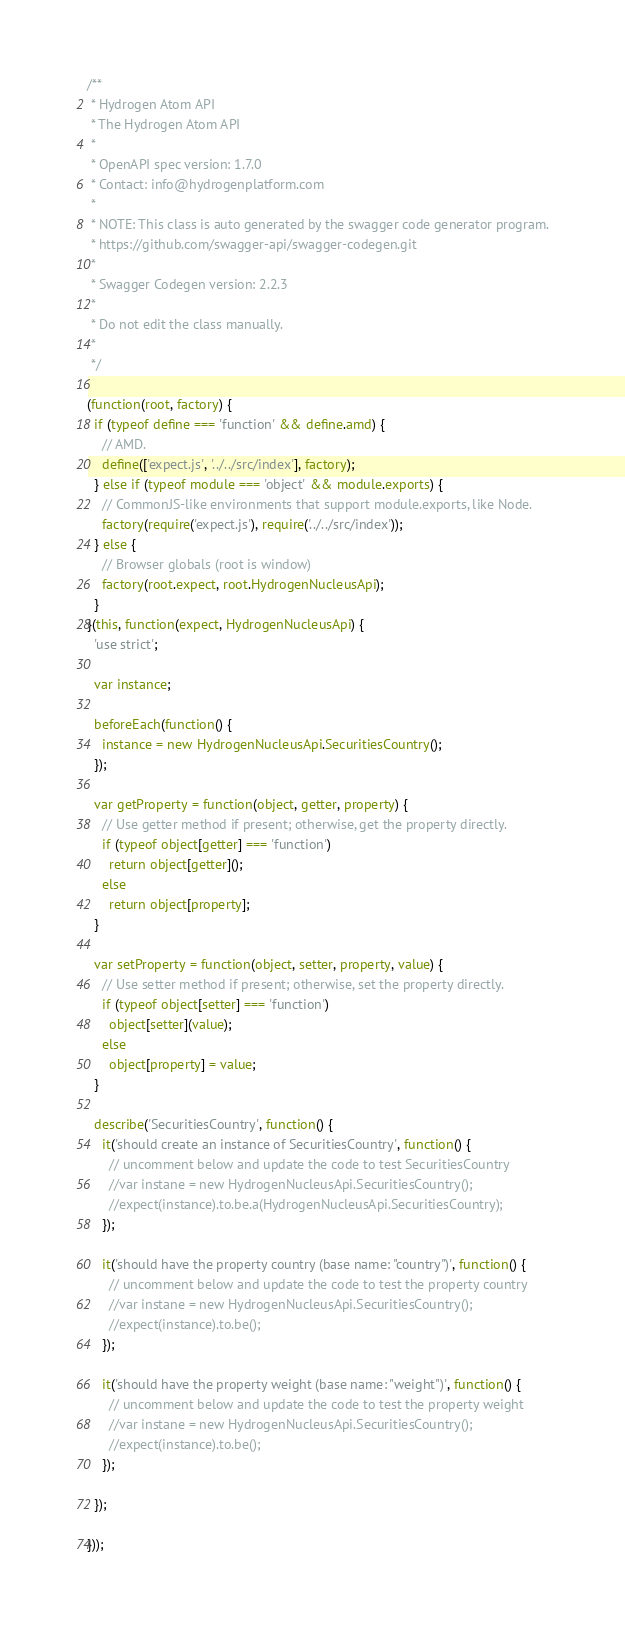<code> <loc_0><loc_0><loc_500><loc_500><_JavaScript_>/**
 * Hydrogen Atom API
 * The Hydrogen Atom API
 *
 * OpenAPI spec version: 1.7.0
 * Contact: info@hydrogenplatform.com
 *
 * NOTE: This class is auto generated by the swagger code generator program.
 * https://github.com/swagger-api/swagger-codegen.git
 *
 * Swagger Codegen version: 2.2.3
 *
 * Do not edit the class manually.
 *
 */

(function(root, factory) {
  if (typeof define === 'function' && define.amd) {
    // AMD.
    define(['expect.js', '../../src/index'], factory);
  } else if (typeof module === 'object' && module.exports) {
    // CommonJS-like environments that support module.exports, like Node.
    factory(require('expect.js'), require('../../src/index'));
  } else {
    // Browser globals (root is window)
    factory(root.expect, root.HydrogenNucleusApi);
  }
}(this, function(expect, HydrogenNucleusApi) {
  'use strict';

  var instance;

  beforeEach(function() {
    instance = new HydrogenNucleusApi.SecuritiesCountry();
  });

  var getProperty = function(object, getter, property) {
    // Use getter method if present; otherwise, get the property directly.
    if (typeof object[getter] === 'function')
      return object[getter]();
    else
      return object[property];
  }

  var setProperty = function(object, setter, property, value) {
    // Use setter method if present; otherwise, set the property directly.
    if (typeof object[setter] === 'function')
      object[setter](value);
    else
      object[property] = value;
  }

  describe('SecuritiesCountry', function() {
    it('should create an instance of SecuritiesCountry', function() {
      // uncomment below and update the code to test SecuritiesCountry
      //var instane = new HydrogenNucleusApi.SecuritiesCountry();
      //expect(instance).to.be.a(HydrogenNucleusApi.SecuritiesCountry);
    });

    it('should have the property country (base name: "country")', function() {
      // uncomment below and update the code to test the property country
      //var instane = new HydrogenNucleusApi.SecuritiesCountry();
      //expect(instance).to.be();
    });

    it('should have the property weight (base name: "weight")', function() {
      // uncomment below and update the code to test the property weight
      //var instane = new HydrogenNucleusApi.SecuritiesCountry();
      //expect(instance).to.be();
    });

  });

}));
</code> 